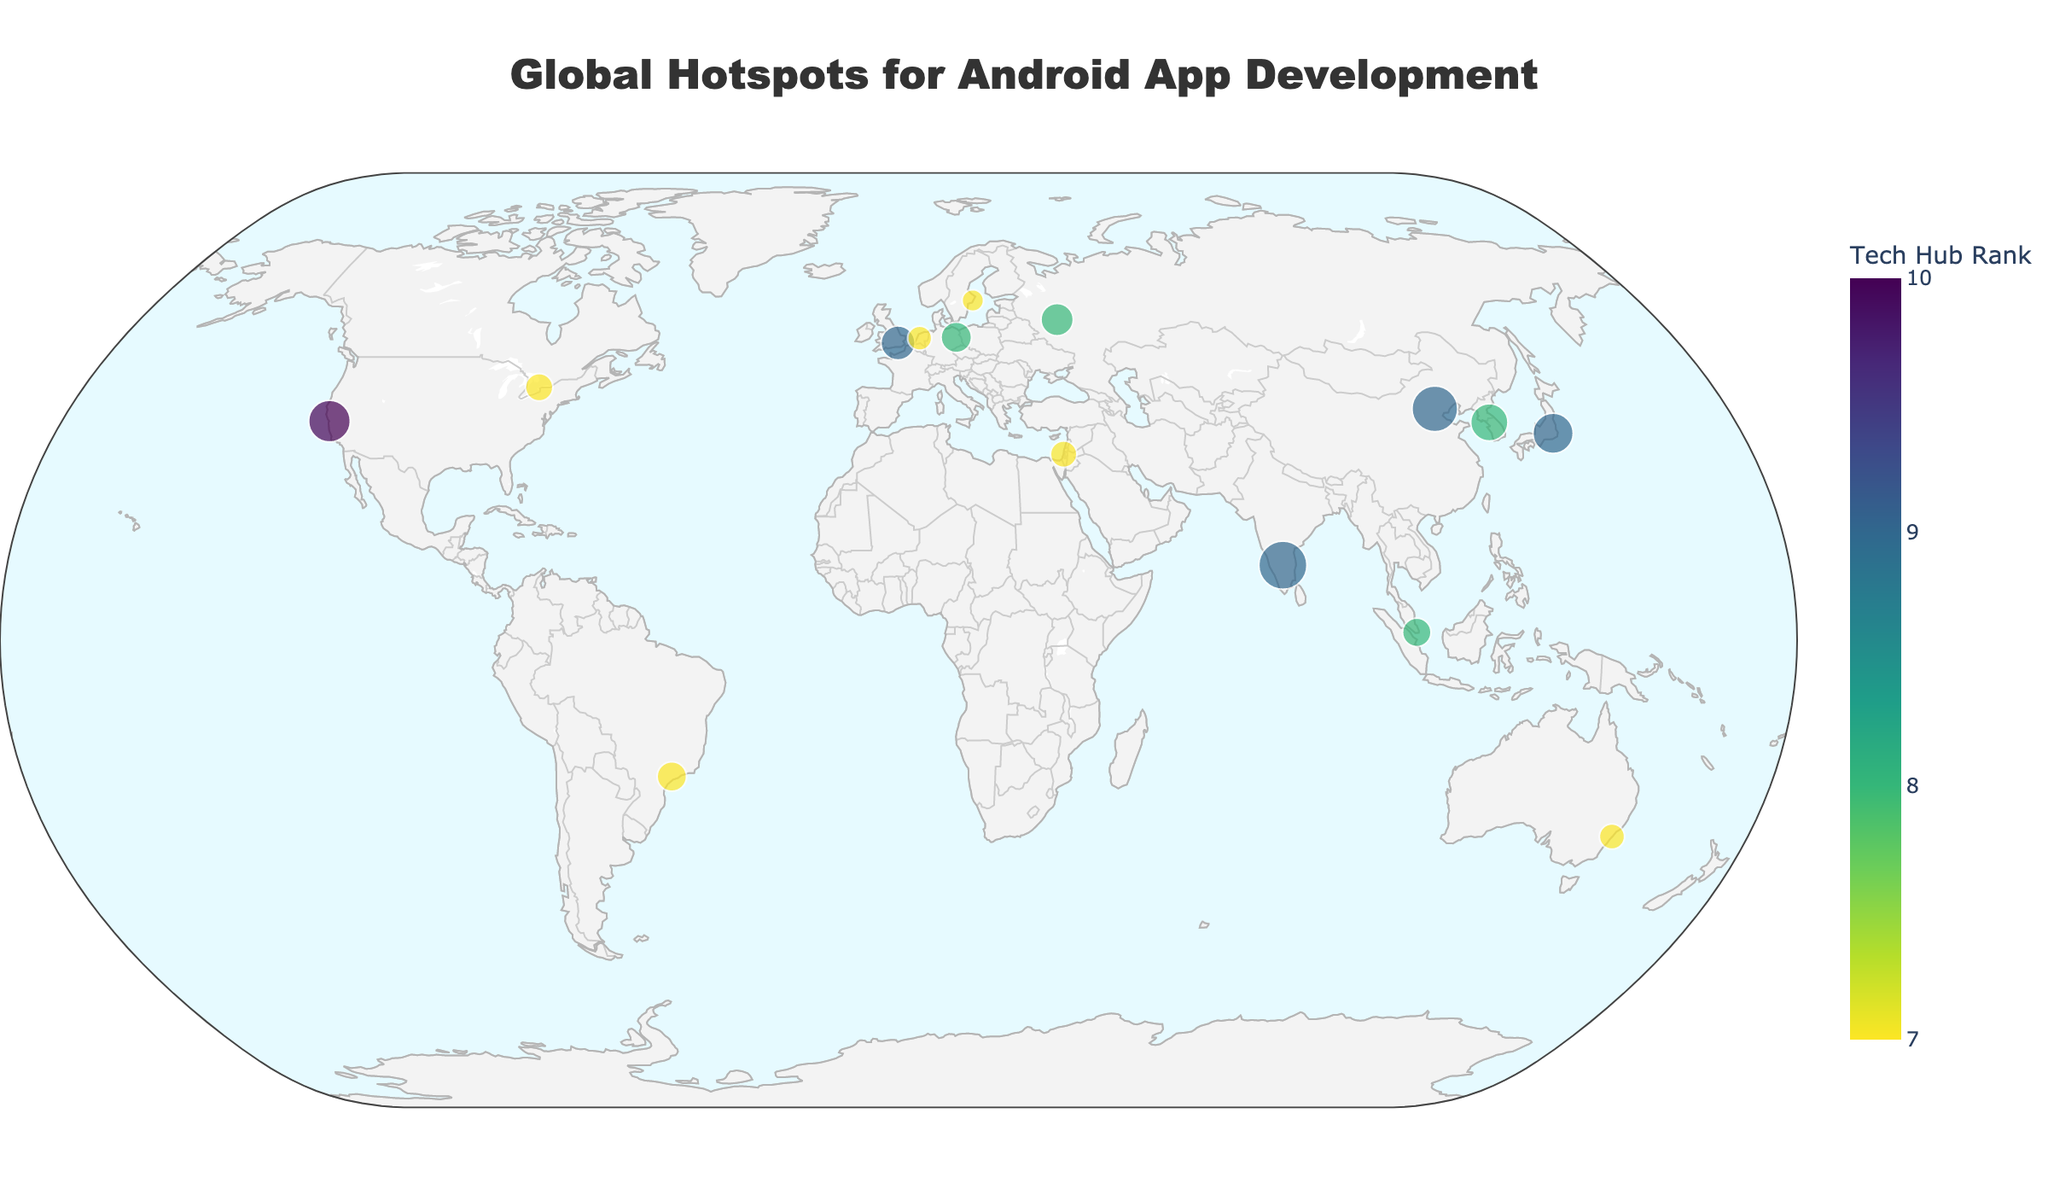What is the title of the plot? The title is usually displayed at the top of the plot. In this case, the title states "Global Hotspots for Android App Development".
Answer: Global Hotspots for Android App Development How many cities are shown on the plot? Each marker on the plot represents a city. By counting these markers, you can determine there are 15 cities represented.
Answer: 15 Which city has the largest number of Android developers? The size of the markers is proportional to the number of Android developers. The largest marker corresponds to the city with the most developers. From the given data, Bangalore has the largest number of Android developers at 20,000.
Answer: Bangalore What color scale is used to represent the Tech Hub Rank? The color of the markers is from the "Viridis" color scale, showing different rankings as visual gradients. The legend on the plot indicates ranks from 7 to 10.
Answer: Viridis Which city has the highest Tech Hub Rank and where is it located? The Tech Hub Rank is visualized with color, where the highest rank color can be observed. San Francisco has the highest Tech Hub Rank of 10, and it’s located in the USA.
Answer: San Francisco Which two cities have the same Tech Hub Rank and are in different continents? By identifying colors associated with the same ranking value and locating the coordinates, Berlin (Germany) and Moscow (Russia) both have a rank of 8 and are in different continents, Europe and Russia respectively.
Answer: Berlin and Moscow What is the average number of Android developers in cities with a Tech Hub Rank of 7? Calculate the average number of Android developers for cities with a rank of 7 by summing the counts and dividing by the number of such cities. The cities are Tel Aviv (6000), Stockholm (4000), Toronto (6500), Amsterdam (5000), Sydney (5500), São Paulo (7500). The average is (6000 + 4000 + 6500 + 5000 + 5500 + 7500)/6 = 5750.
Answer: 5750 Which city is represented by the marker located at approximately latitude 35.6762 and longitude 139.6503? Each marker’s coordinates indicate a city’s location. For latitude 35.6762 and longitude 139.6503, the city is Tokyo, Japan.
Answer: Tokyo Is there an observable pattern in the distribution of Android developers in relation to the geographical location of these cities? By examining the plot, it's observable that highly concentrated clusters of Android developers are located in notable tech hubs across North America, Europe, and Asia. This suggests higher densities in economically developed areas and established tech ecosystems.
Answer: Yes Which city near the equator has a significant number of Android developers and a Tech Hub Rank of 9? By identifying cities close to the equator and checking their developer count and rank, Singapore fits this criterion with 7,000 developers and a rank of 8.
Answer: Singapore 